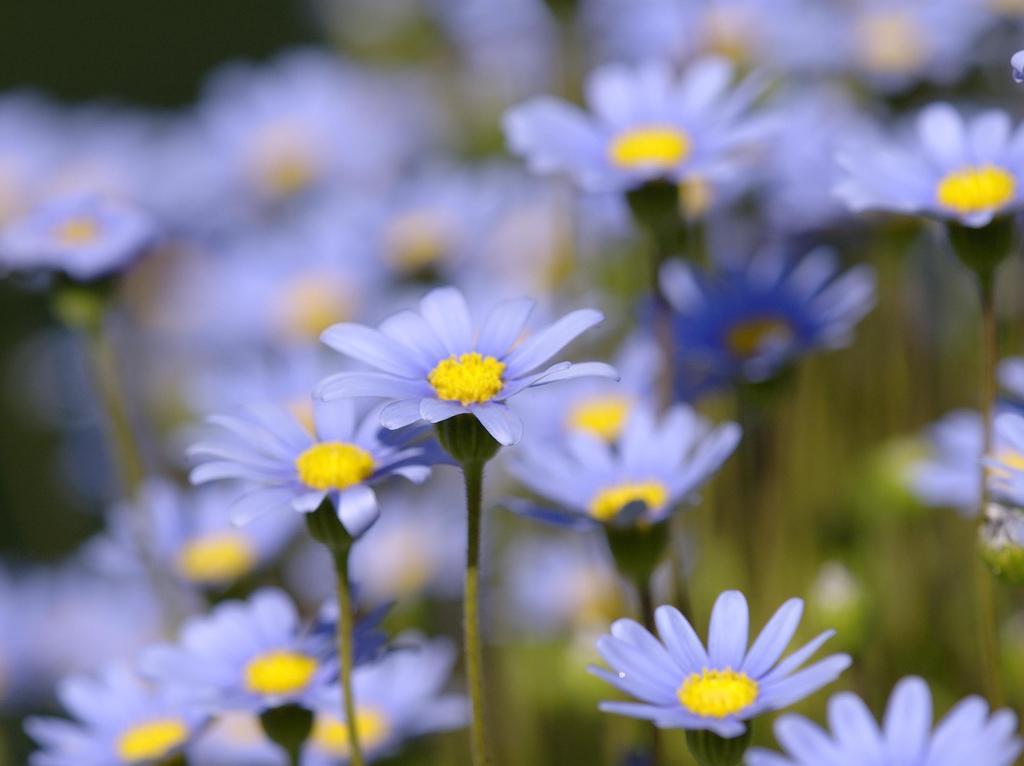Please provide a concise description of this image. In this image I can see many blue color flowers to the stems. The middle part of the flowers is in yellow color. The background in blurred. 